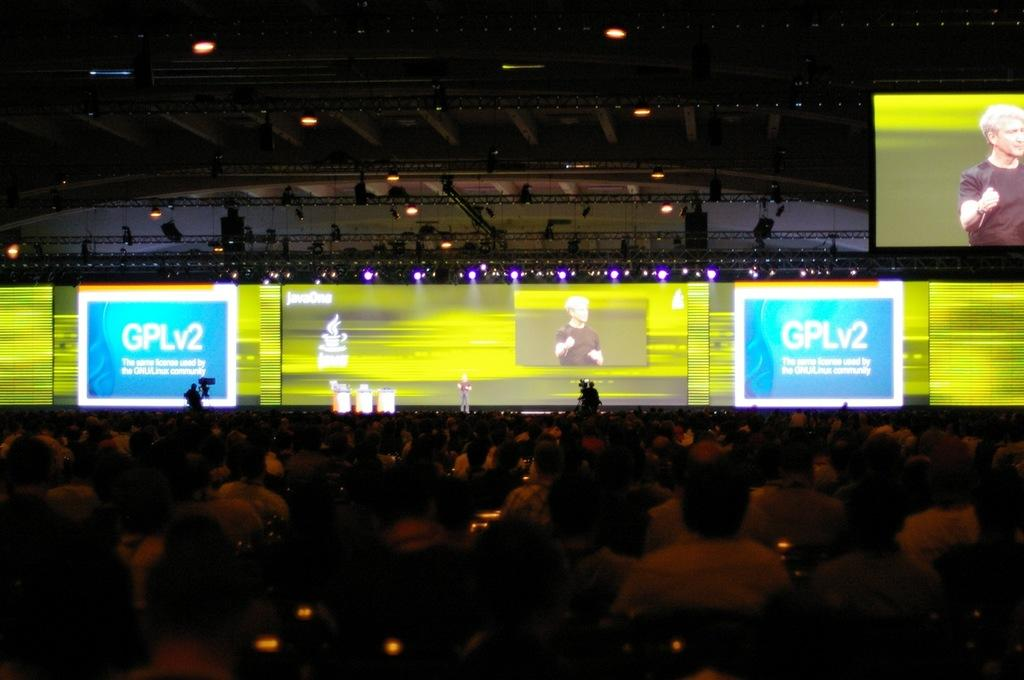What are the people in the image doing? The people in the image are sitting on chairs. What can be seen on the stage in the image? There are projector screens on the stage. Is there a projector screen in a location other than the stage in the image? Yes, there is a projector screen on the top of the stage or another location in the image. What type of lettuce is being used as a decoration on the chairs in the image? There is no lettuce present in the image; it features people sitting on chairs and projector screens. 